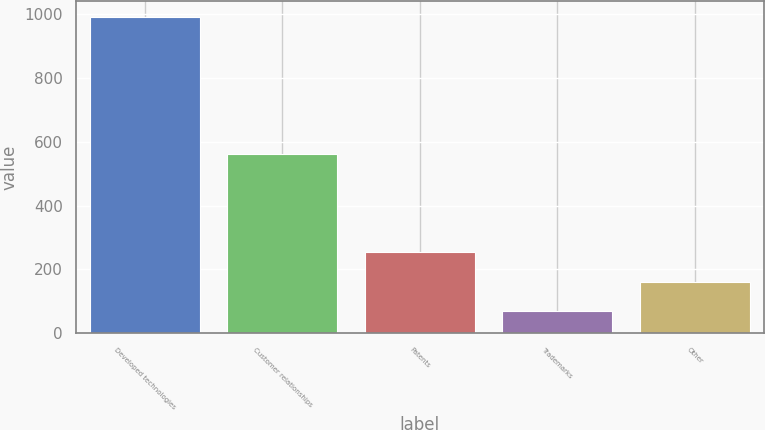Convert chart. <chart><loc_0><loc_0><loc_500><loc_500><bar_chart><fcel>Developed technologies<fcel>Customer relationships<fcel>Patents<fcel>Trademarks<fcel>Other<nl><fcel>990<fcel>562<fcel>253.2<fcel>69<fcel>161.1<nl></chart> 